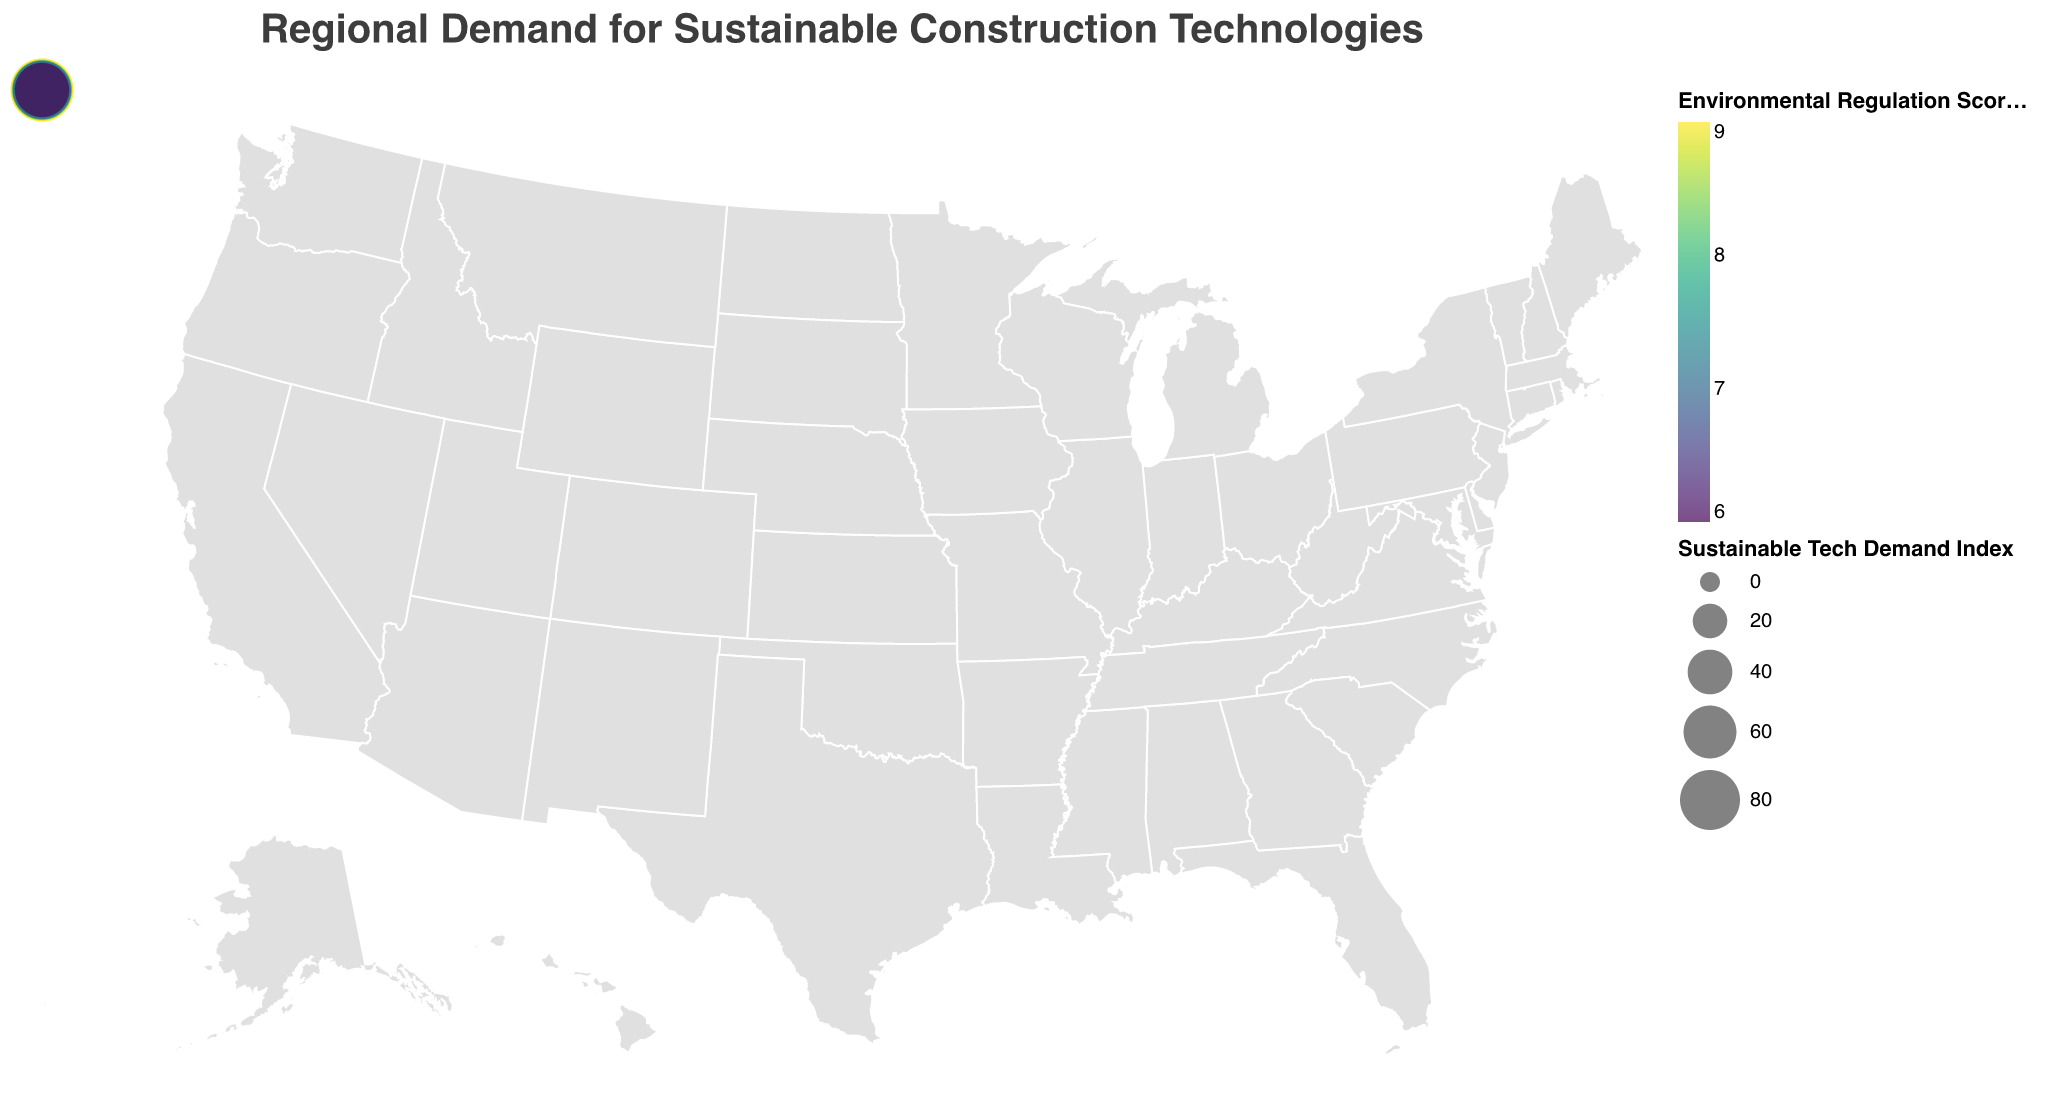What is the title of the figure? The title is typically displayed at the top of the figure and provides a summary of what the figure is about. In this case, it is "Regional Demand for Sustainable Construction Technologies."
Answer: Regional Demand for Sustainable Construction Technologies Which region has the highest adoption rate for sustainable construction technologies? The adoption rate is shown in percentage. By observing the figure, Oregon has the highest adoption rate of 82%.
Answer: Oregon Which region has the lowest adoption rate for sustainable construction technologies? Just like the highest, we look for the smallest number in the adoption rate column. Georgia has the lowest adoption rate at 58%.
Answer: Georgia Which region scores the highest on the Environmental Regulation Score? The Environmental Regulation Score is given on a scale from 1-10. Oregon, Washington, and California each have a score of 9.
Answer: Oregon, Washington, California What is the Sustainable Tech Demand Index for California? The Sustainable Tech Demand Index for California is displayed as part of the tooltip information in the figure. It is 85 for California.
Answer: 85 What is the average adoption rate across all regions? To find the average, sum up all the adoption rates and divide by the number of regions. Total = 1333, Number of regions = 19, Average = 1333/19 = 70.16
Answer: 70.16% Compare the Environmental Regulation Score between Texas and New York. Texas has an Environmental Regulation Score of 6, while New York has a score of 8. Hence, New York has a higher score.
Answer: New York Is there a relationship between Environmental Regulation Score and Sustainable Tech Demand Index? Generally, regions with higher Environmental Regulation Scores tend to have higher Sustainable Tech Demand Indexes. For example, Oregon has a score of 9 and a demand index of 90, while Texas has a score of 6 and a demand index of 70.
Answer: Generally yes Which region has the highest Sustainable Tech Demand Index and what is the Adoption Rate there? Oregon has the highest Sustainable Tech Demand Index of 90, and its adoption rate is 82%.
Answer: Oregon with 82% adoption rate What is the discrepancy in the Sustainable Tech Demand Index between the highest and lowest regions? The highest Sustainable Tech Demand Index is 90 (Oregon), and the lowest is 63 (Georgia). The discrepancy is 90 - 63 = 27.
Answer: 27 